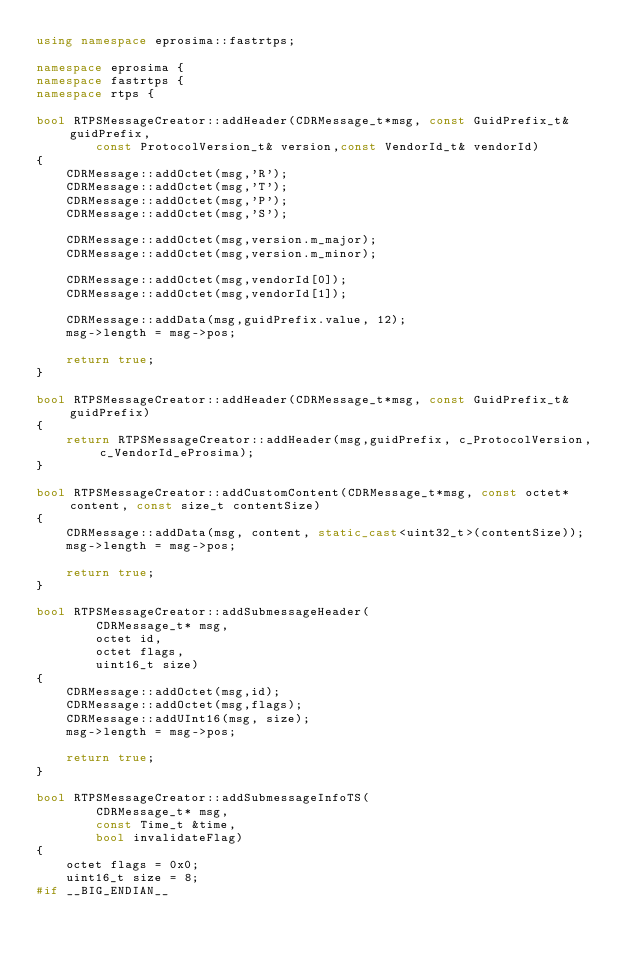Convert code to text. <code><loc_0><loc_0><loc_500><loc_500><_C++_>using namespace eprosima::fastrtps;

namespace eprosima {
namespace fastrtps {
namespace rtps {

bool RTPSMessageCreator::addHeader(CDRMessage_t*msg, const GuidPrefix_t& guidPrefix,
        const ProtocolVersion_t& version,const VendorId_t& vendorId)
{
    CDRMessage::addOctet(msg,'R');
    CDRMessage::addOctet(msg,'T');
    CDRMessage::addOctet(msg,'P');
    CDRMessage::addOctet(msg,'S');

    CDRMessage::addOctet(msg,version.m_major);
    CDRMessage::addOctet(msg,version.m_minor);

    CDRMessage::addOctet(msg,vendorId[0]);
    CDRMessage::addOctet(msg,vendorId[1]);

    CDRMessage::addData(msg,guidPrefix.value, 12);
    msg->length = msg->pos;

    return true;
}

bool RTPSMessageCreator::addHeader(CDRMessage_t*msg, const GuidPrefix_t& guidPrefix)
{
    return RTPSMessageCreator::addHeader(msg,guidPrefix, c_ProtocolVersion,c_VendorId_eProsima);
}

bool RTPSMessageCreator::addCustomContent(CDRMessage_t*msg, const octet* content, const size_t contentSize)
{
    CDRMessage::addData(msg, content, static_cast<uint32_t>(contentSize));
    msg->length = msg->pos;

    return true;
}

bool RTPSMessageCreator::addSubmessageHeader(
        CDRMessage_t* msg,
        octet id,
        octet flags,
        uint16_t size)
{
    CDRMessage::addOctet(msg,id);
    CDRMessage::addOctet(msg,flags);
    CDRMessage::addUInt16(msg, size);
    msg->length = msg->pos;

    return true;
}

bool RTPSMessageCreator::addSubmessageInfoTS(
        CDRMessage_t* msg,
        const Time_t &time,
        bool invalidateFlag)
{
    octet flags = 0x0;
    uint16_t size = 8;
#if __BIG_ENDIAN__</code> 